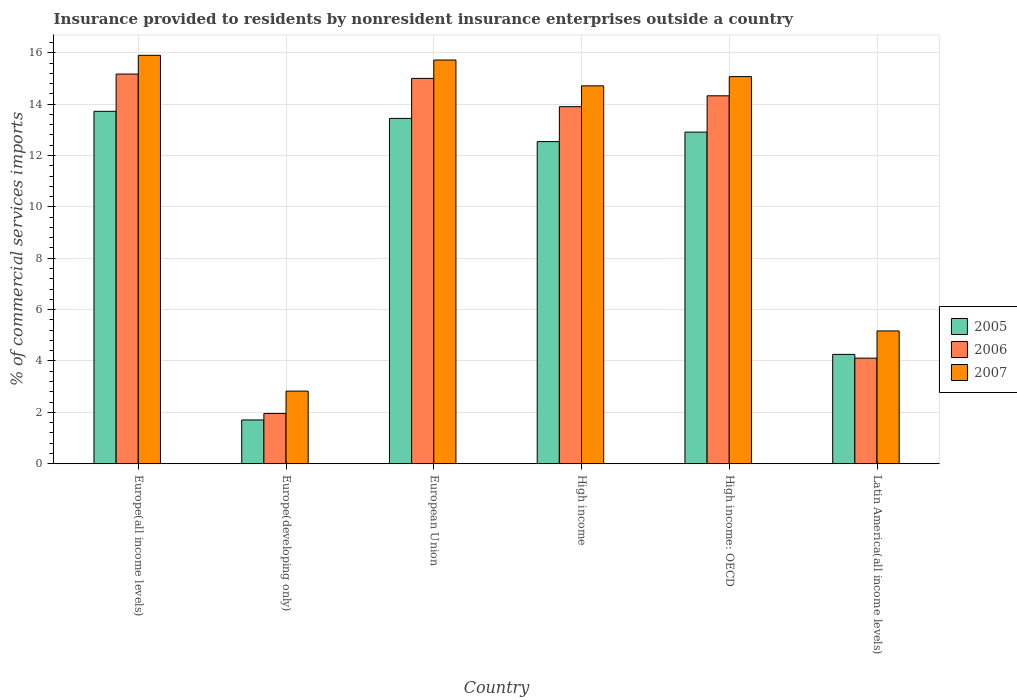How many different coloured bars are there?
Make the answer very short. 3. Are the number of bars on each tick of the X-axis equal?
Ensure brevity in your answer.  Yes. In how many cases, is the number of bars for a given country not equal to the number of legend labels?
Your response must be concise. 0. What is the Insurance provided to residents in 2005 in High income: OECD?
Your answer should be very brief. 12.91. Across all countries, what is the maximum Insurance provided to residents in 2005?
Provide a short and direct response. 13.72. Across all countries, what is the minimum Insurance provided to residents in 2006?
Offer a terse response. 1.96. In which country was the Insurance provided to residents in 2005 maximum?
Your response must be concise. Europe(all income levels). In which country was the Insurance provided to residents in 2005 minimum?
Offer a very short reply. Europe(developing only). What is the total Insurance provided to residents in 2005 in the graph?
Offer a terse response. 58.58. What is the difference between the Insurance provided to residents in 2006 in Europe(developing only) and that in High income?
Give a very brief answer. -11.94. What is the difference between the Insurance provided to residents in 2005 in Latin America(all income levels) and the Insurance provided to residents in 2006 in Europe(all income levels)?
Your answer should be compact. -10.91. What is the average Insurance provided to residents in 2005 per country?
Your answer should be compact. 9.76. What is the difference between the Insurance provided to residents of/in 2007 and Insurance provided to residents of/in 2005 in Latin America(all income levels)?
Offer a terse response. 0.91. In how many countries, is the Insurance provided to residents in 2007 greater than 8.4 %?
Offer a very short reply. 4. What is the ratio of the Insurance provided to residents in 2007 in Europe(developing only) to that in Latin America(all income levels)?
Give a very brief answer. 0.55. Is the difference between the Insurance provided to residents in 2007 in Europe(developing only) and High income: OECD greater than the difference between the Insurance provided to residents in 2005 in Europe(developing only) and High income: OECD?
Offer a very short reply. No. What is the difference between the highest and the second highest Insurance provided to residents in 2006?
Ensure brevity in your answer.  0.68. What is the difference between the highest and the lowest Insurance provided to residents in 2006?
Your answer should be compact. 13.21. In how many countries, is the Insurance provided to residents in 2005 greater than the average Insurance provided to residents in 2005 taken over all countries?
Provide a short and direct response. 4. Is it the case that in every country, the sum of the Insurance provided to residents in 2007 and Insurance provided to residents in 2006 is greater than the Insurance provided to residents in 2005?
Your response must be concise. Yes. How many bars are there?
Give a very brief answer. 18. Does the graph contain any zero values?
Offer a terse response. No. How are the legend labels stacked?
Provide a succinct answer. Vertical. What is the title of the graph?
Make the answer very short. Insurance provided to residents by nonresident insurance enterprises outside a country. Does "1973" appear as one of the legend labels in the graph?
Your answer should be compact. No. What is the label or title of the Y-axis?
Provide a succinct answer. % of commercial services imports. What is the % of commercial services imports in 2005 in Europe(all income levels)?
Ensure brevity in your answer.  13.72. What is the % of commercial services imports in 2006 in Europe(all income levels)?
Keep it short and to the point. 15.17. What is the % of commercial services imports in 2007 in Europe(all income levels)?
Offer a very short reply. 15.9. What is the % of commercial services imports of 2005 in Europe(developing only)?
Provide a short and direct response. 1.7. What is the % of commercial services imports of 2006 in Europe(developing only)?
Your answer should be compact. 1.96. What is the % of commercial services imports in 2007 in Europe(developing only)?
Offer a terse response. 2.83. What is the % of commercial services imports in 2005 in European Union?
Your answer should be compact. 13.45. What is the % of commercial services imports of 2006 in European Union?
Your response must be concise. 15. What is the % of commercial services imports in 2007 in European Union?
Offer a terse response. 15.72. What is the % of commercial services imports in 2005 in High income?
Your response must be concise. 12.54. What is the % of commercial services imports in 2006 in High income?
Provide a short and direct response. 13.9. What is the % of commercial services imports in 2007 in High income?
Offer a very short reply. 14.71. What is the % of commercial services imports in 2005 in High income: OECD?
Ensure brevity in your answer.  12.91. What is the % of commercial services imports of 2006 in High income: OECD?
Keep it short and to the point. 14.33. What is the % of commercial services imports of 2007 in High income: OECD?
Make the answer very short. 15.07. What is the % of commercial services imports of 2005 in Latin America(all income levels)?
Keep it short and to the point. 4.26. What is the % of commercial services imports of 2006 in Latin America(all income levels)?
Provide a succinct answer. 4.11. What is the % of commercial services imports in 2007 in Latin America(all income levels)?
Ensure brevity in your answer.  5.17. Across all countries, what is the maximum % of commercial services imports of 2005?
Provide a short and direct response. 13.72. Across all countries, what is the maximum % of commercial services imports of 2006?
Give a very brief answer. 15.17. Across all countries, what is the maximum % of commercial services imports of 2007?
Provide a short and direct response. 15.9. Across all countries, what is the minimum % of commercial services imports of 2005?
Offer a terse response. 1.7. Across all countries, what is the minimum % of commercial services imports in 2006?
Make the answer very short. 1.96. Across all countries, what is the minimum % of commercial services imports of 2007?
Ensure brevity in your answer.  2.83. What is the total % of commercial services imports of 2005 in the graph?
Provide a succinct answer. 58.58. What is the total % of commercial services imports of 2006 in the graph?
Your answer should be very brief. 64.47. What is the total % of commercial services imports of 2007 in the graph?
Keep it short and to the point. 69.4. What is the difference between the % of commercial services imports in 2005 in Europe(all income levels) and that in Europe(developing only)?
Give a very brief answer. 12.02. What is the difference between the % of commercial services imports of 2006 in Europe(all income levels) and that in Europe(developing only)?
Offer a terse response. 13.21. What is the difference between the % of commercial services imports in 2007 in Europe(all income levels) and that in Europe(developing only)?
Offer a very short reply. 13.07. What is the difference between the % of commercial services imports in 2005 in Europe(all income levels) and that in European Union?
Provide a succinct answer. 0.28. What is the difference between the % of commercial services imports in 2006 in Europe(all income levels) and that in European Union?
Give a very brief answer. 0.17. What is the difference between the % of commercial services imports in 2007 in Europe(all income levels) and that in European Union?
Offer a very short reply. 0.18. What is the difference between the % of commercial services imports of 2005 in Europe(all income levels) and that in High income?
Your answer should be very brief. 1.18. What is the difference between the % of commercial services imports of 2006 in Europe(all income levels) and that in High income?
Offer a terse response. 1.27. What is the difference between the % of commercial services imports of 2007 in Europe(all income levels) and that in High income?
Your answer should be very brief. 1.19. What is the difference between the % of commercial services imports of 2005 in Europe(all income levels) and that in High income: OECD?
Your answer should be compact. 0.81. What is the difference between the % of commercial services imports of 2006 in Europe(all income levels) and that in High income: OECD?
Provide a short and direct response. 0.85. What is the difference between the % of commercial services imports in 2007 in Europe(all income levels) and that in High income: OECD?
Your response must be concise. 0.83. What is the difference between the % of commercial services imports of 2005 in Europe(all income levels) and that in Latin America(all income levels)?
Offer a very short reply. 9.46. What is the difference between the % of commercial services imports of 2006 in Europe(all income levels) and that in Latin America(all income levels)?
Your answer should be compact. 11.06. What is the difference between the % of commercial services imports of 2007 in Europe(all income levels) and that in Latin America(all income levels)?
Give a very brief answer. 10.73. What is the difference between the % of commercial services imports in 2005 in Europe(developing only) and that in European Union?
Your response must be concise. -11.74. What is the difference between the % of commercial services imports in 2006 in Europe(developing only) and that in European Union?
Your answer should be compact. -13.05. What is the difference between the % of commercial services imports of 2007 in Europe(developing only) and that in European Union?
Make the answer very short. -12.89. What is the difference between the % of commercial services imports in 2005 in Europe(developing only) and that in High income?
Provide a short and direct response. -10.84. What is the difference between the % of commercial services imports of 2006 in Europe(developing only) and that in High income?
Give a very brief answer. -11.94. What is the difference between the % of commercial services imports of 2007 in Europe(developing only) and that in High income?
Give a very brief answer. -11.88. What is the difference between the % of commercial services imports in 2005 in Europe(developing only) and that in High income: OECD?
Keep it short and to the point. -11.21. What is the difference between the % of commercial services imports in 2006 in Europe(developing only) and that in High income: OECD?
Ensure brevity in your answer.  -12.37. What is the difference between the % of commercial services imports in 2007 in Europe(developing only) and that in High income: OECD?
Provide a succinct answer. -12.24. What is the difference between the % of commercial services imports in 2005 in Europe(developing only) and that in Latin America(all income levels)?
Give a very brief answer. -2.55. What is the difference between the % of commercial services imports of 2006 in Europe(developing only) and that in Latin America(all income levels)?
Ensure brevity in your answer.  -2.15. What is the difference between the % of commercial services imports in 2007 in Europe(developing only) and that in Latin America(all income levels)?
Your answer should be very brief. -2.34. What is the difference between the % of commercial services imports of 2005 in European Union and that in High income?
Provide a succinct answer. 0.9. What is the difference between the % of commercial services imports in 2006 in European Union and that in High income?
Your answer should be compact. 1.1. What is the difference between the % of commercial services imports of 2007 in European Union and that in High income?
Make the answer very short. 1.01. What is the difference between the % of commercial services imports in 2005 in European Union and that in High income: OECD?
Provide a succinct answer. 0.53. What is the difference between the % of commercial services imports in 2006 in European Union and that in High income: OECD?
Make the answer very short. 0.68. What is the difference between the % of commercial services imports in 2007 in European Union and that in High income: OECD?
Your answer should be compact. 0.64. What is the difference between the % of commercial services imports of 2005 in European Union and that in Latin America(all income levels)?
Provide a short and direct response. 9.19. What is the difference between the % of commercial services imports in 2006 in European Union and that in Latin America(all income levels)?
Your answer should be very brief. 10.89. What is the difference between the % of commercial services imports in 2007 in European Union and that in Latin America(all income levels)?
Provide a short and direct response. 10.55. What is the difference between the % of commercial services imports in 2005 in High income and that in High income: OECD?
Your response must be concise. -0.37. What is the difference between the % of commercial services imports in 2006 in High income and that in High income: OECD?
Keep it short and to the point. -0.42. What is the difference between the % of commercial services imports of 2007 in High income and that in High income: OECD?
Give a very brief answer. -0.36. What is the difference between the % of commercial services imports of 2005 in High income and that in Latin America(all income levels)?
Ensure brevity in your answer.  8.28. What is the difference between the % of commercial services imports in 2006 in High income and that in Latin America(all income levels)?
Offer a very short reply. 9.79. What is the difference between the % of commercial services imports in 2007 in High income and that in Latin America(all income levels)?
Provide a short and direct response. 9.54. What is the difference between the % of commercial services imports of 2005 in High income: OECD and that in Latin America(all income levels)?
Your answer should be very brief. 8.65. What is the difference between the % of commercial services imports of 2006 in High income: OECD and that in Latin America(all income levels)?
Provide a succinct answer. 10.21. What is the difference between the % of commercial services imports in 2007 in High income: OECD and that in Latin America(all income levels)?
Offer a terse response. 9.9. What is the difference between the % of commercial services imports in 2005 in Europe(all income levels) and the % of commercial services imports in 2006 in Europe(developing only)?
Provide a short and direct response. 11.76. What is the difference between the % of commercial services imports of 2005 in Europe(all income levels) and the % of commercial services imports of 2007 in Europe(developing only)?
Offer a terse response. 10.89. What is the difference between the % of commercial services imports in 2006 in Europe(all income levels) and the % of commercial services imports in 2007 in Europe(developing only)?
Your answer should be compact. 12.34. What is the difference between the % of commercial services imports in 2005 in Europe(all income levels) and the % of commercial services imports in 2006 in European Union?
Ensure brevity in your answer.  -1.28. What is the difference between the % of commercial services imports of 2005 in Europe(all income levels) and the % of commercial services imports of 2007 in European Union?
Your answer should be compact. -2. What is the difference between the % of commercial services imports of 2006 in Europe(all income levels) and the % of commercial services imports of 2007 in European Union?
Keep it short and to the point. -0.55. What is the difference between the % of commercial services imports of 2005 in Europe(all income levels) and the % of commercial services imports of 2006 in High income?
Offer a very short reply. -0.18. What is the difference between the % of commercial services imports in 2005 in Europe(all income levels) and the % of commercial services imports in 2007 in High income?
Offer a terse response. -0.99. What is the difference between the % of commercial services imports in 2006 in Europe(all income levels) and the % of commercial services imports in 2007 in High income?
Offer a terse response. 0.46. What is the difference between the % of commercial services imports in 2005 in Europe(all income levels) and the % of commercial services imports in 2006 in High income: OECD?
Provide a short and direct response. -0.6. What is the difference between the % of commercial services imports in 2005 in Europe(all income levels) and the % of commercial services imports in 2007 in High income: OECD?
Your answer should be very brief. -1.35. What is the difference between the % of commercial services imports in 2006 in Europe(all income levels) and the % of commercial services imports in 2007 in High income: OECD?
Your answer should be compact. 0.1. What is the difference between the % of commercial services imports of 2005 in Europe(all income levels) and the % of commercial services imports of 2006 in Latin America(all income levels)?
Give a very brief answer. 9.61. What is the difference between the % of commercial services imports of 2005 in Europe(all income levels) and the % of commercial services imports of 2007 in Latin America(all income levels)?
Offer a terse response. 8.55. What is the difference between the % of commercial services imports in 2006 in Europe(all income levels) and the % of commercial services imports in 2007 in Latin America(all income levels)?
Make the answer very short. 10. What is the difference between the % of commercial services imports of 2005 in Europe(developing only) and the % of commercial services imports of 2006 in European Union?
Give a very brief answer. -13.3. What is the difference between the % of commercial services imports of 2005 in Europe(developing only) and the % of commercial services imports of 2007 in European Union?
Offer a terse response. -14.01. What is the difference between the % of commercial services imports in 2006 in Europe(developing only) and the % of commercial services imports in 2007 in European Union?
Your response must be concise. -13.76. What is the difference between the % of commercial services imports of 2005 in Europe(developing only) and the % of commercial services imports of 2006 in High income?
Offer a terse response. -12.2. What is the difference between the % of commercial services imports in 2005 in Europe(developing only) and the % of commercial services imports in 2007 in High income?
Your answer should be compact. -13.01. What is the difference between the % of commercial services imports of 2006 in Europe(developing only) and the % of commercial services imports of 2007 in High income?
Your response must be concise. -12.75. What is the difference between the % of commercial services imports in 2005 in Europe(developing only) and the % of commercial services imports in 2006 in High income: OECD?
Keep it short and to the point. -12.62. What is the difference between the % of commercial services imports in 2005 in Europe(developing only) and the % of commercial services imports in 2007 in High income: OECD?
Provide a short and direct response. -13.37. What is the difference between the % of commercial services imports in 2006 in Europe(developing only) and the % of commercial services imports in 2007 in High income: OECD?
Offer a very short reply. -13.11. What is the difference between the % of commercial services imports in 2005 in Europe(developing only) and the % of commercial services imports in 2006 in Latin America(all income levels)?
Your response must be concise. -2.41. What is the difference between the % of commercial services imports in 2005 in Europe(developing only) and the % of commercial services imports in 2007 in Latin America(all income levels)?
Make the answer very short. -3.47. What is the difference between the % of commercial services imports in 2006 in Europe(developing only) and the % of commercial services imports in 2007 in Latin America(all income levels)?
Provide a succinct answer. -3.21. What is the difference between the % of commercial services imports in 2005 in European Union and the % of commercial services imports in 2006 in High income?
Make the answer very short. -0.46. What is the difference between the % of commercial services imports in 2005 in European Union and the % of commercial services imports in 2007 in High income?
Give a very brief answer. -1.27. What is the difference between the % of commercial services imports in 2006 in European Union and the % of commercial services imports in 2007 in High income?
Your answer should be compact. 0.29. What is the difference between the % of commercial services imports of 2005 in European Union and the % of commercial services imports of 2006 in High income: OECD?
Provide a succinct answer. -0.88. What is the difference between the % of commercial services imports in 2005 in European Union and the % of commercial services imports in 2007 in High income: OECD?
Offer a terse response. -1.63. What is the difference between the % of commercial services imports in 2006 in European Union and the % of commercial services imports in 2007 in High income: OECD?
Give a very brief answer. -0.07. What is the difference between the % of commercial services imports in 2005 in European Union and the % of commercial services imports in 2006 in Latin America(all income levels)?
Give a very brief answer. 9.34. What is the difference between the % of commercial services imports in 2005 in European Union and the % of commercial services imports in 2007 in Latin America(all income levels)?
Keep it short and to the point. 8.28. What is the difference between the % of commercial services imports in 2006 in European Union and the % of commercial services imports in 2007 in Latin America(all income levels)?
Provide a short and direct response. 9.83. What is the difference between the % of commercial services imports in 2005 in High income and the % of commercial services imports in 2006 in High income: OECD?
Your answer should be very brief. -1.78. What is the difference between the % of commercial services imports in 2005 in High income and the % of commercial services imports in 2007 in High income: OECD?
Make the answer very short. -2.53. What is the difference between the % of commercial services imports of 2006 in High income and the % of commercial services imports of 2007 in High income: OECD?
Your response must be concise. -1.17. What is the difference between the % of commercial services imports in 2005 in High income and the % of commercial services imports in 2006 in Latin America(all income levels)?
Offer a terse response. 8.43. What is the difference between the % of commercial services imports in 2005 in High income and the % of commercial services imports in 2007 in Latin America(all income levels)?
Keep it short and to the point. 7.37. What is the difference between the % of commercial services imports of 2006 in High income and the % of commercial services imports of 2007 in Latin America(all income levels)?
Your answer should be compact. 8.73. What is the difference between the % of commercial services imports in 2005 in High income: OECD and the % of commercial services imports in 2006 in Latin America(all income levels)?
Provide a succinct answer. 8.8. What is the difference between the % of commercial services imports in 2005 in High income: OECD and the % of commercial services imports in 2007 in Latin America(all income levels)?
Your answer should be compact. 7.74. What is the difference between the % of commercial services imports of 2006 in High income: OECD and the % of commercial services imports of 2007 in Latin America(all income levels)?
Your answer should be very brief. 9.15. What is the average % of commercial services imports in 2005 per country?
Offer a very short reply. 9.76. What is the average % of commercial services imports of 2006 per country?
Keep it short and to the point. 10.75. What is the average % of commercial services imports in 2007 per country?
Provide a succinct answer. 11.57. What is the difference between the % of commercial services imports of 2005 and % of commercial services imports of 2006 in Europe(all income levels)?
Offer a very short reply. -1.45. What is the difference between the % of commercial services imports of 2005 and % of commercial services imports of 2007 in Europe(all income levels)?
Make the answer very short. -2.18. What is the difference between the % of commercial services imports of 2006 and % of commercial services imports of 2007 in Europe(all income levels)?
Give a very brief answer. -0.73. What is the difference between the % of commercial services imports of 2005 and % of commercial services imports of 2006 in Europe(developing only)?
Make the answer very short. -0.25. What is the difference between the % of commercial services imports of 2005 and % of commercial services imports of 2007 in Europe(developing only)?
Provide a succinct answer. -1.12. What is the difference between the % of commercial services imports in 2006 and % of commercial services imports in 2007 in Europe(developing only)?
Your answer should be very brief. -0.87. What is the difference between the % of commercial services imports in 2005 and % of commercial services imports in 2006 in European Union?
Give a very brief answer. -1.56. What is the difference between the % of commercial services imports of 2005 and % of commercial services imports of 2007 in European Union?
Offer a terse response. -2.27. What is the difference between the % of commercial services imports in 2006 and % of commercial services imports in 2007 in European Union?
Provide a short and direct response. -0.71. What is the difference between the % of commercial services imports in 2005 and % of commercial services imports in 2006 in High income?
Ensure brevity in your answer.  -1.36. What is the difference between the % of commercial services imports in 2005 and % of commercial services imports in 2007 in High income?
Make the answer very short. -2.17. What is the difference between the % of commercial services imports in 2006 and % of commercial services imports in 2007 in High income?
Your answer should be very brief. -0.81. What is the difference between the % of commercial services imports of 2005 and % of commercial services imports of 2006 in High income: OECD?
Give a very brief answer. -1.41. What is the difference between the % of commercial services imports of 2005 and % of commercial services imports of 2007 in High income: OECD?
Keep it short and to the point. -2.16. What is the difference between the % of commercial services imports of 2006 and % of commercial services imports of 2007 in High income: OECD?
Ensure brevity in your answer.  -0.75. What is the difference between the % of commercial services imports in 2005 and % of commercial services imports in 2006 in Latin America(all income levels)?
Your answer should be very brief. 0.15. What is the difference between the % of commercial services imports in 2005 and % of commercial services imports in 2007 in Latin America(all income levels)?
Provide a short and direct response. -0.91. What is the difference between the % of commercial services imports of 2006 and % of commercial services imports of 2007 in Latin America(all income levels)?
Your answer should be very brief. -1.06. What is the ratio of the % of commercial services imports in 2005 in Europe(all income levels) to that in Europe(developing only)?
Offer a terse response. 8.05. What is the ratio of the % of commercial services imports in 2006 in Europe(all income levels) to that in Europe(developing only)?
Your answer should be very brief. 7.75. What is the ratio of the % of commercial services imports of 2007 in Europe(all income levels) to that in Europe(developing only)?
Offer a terse response. 5.62. What is the ratio of the % of commercial services imports in 2005 in Europe(all income levels) to that in European Union?
Your answer should be very brief. 1.02. What is the ratio of the % of commercial services imports in 2006 in Europe(all income levels) to that in European Union?
Keep it short and to the point. 1.01. What is the ratio of the % of commercial services imports in 2007 in Europe(all income levels) to that in European Union?
Make the answer very short. 1.01. What is the ratio of the % of commercial services imports in 2005 in Europe(all income levels) to that in High income?
Your answer should be compact. 1.09. What is the ratio of the % of commercial services imports of 2006 in Europe(all income levels) to that in High income?
Make the answer very short. 1.09. What is the ratio of the % of commercial services imports in 2007 in Europe(all income levels) to that in High income?
Your answer should be compact. 1.08. What is the ratio of the % of commercial services imports of 2005 in Europe(all income levels) to that in High income: OECD?
Your answer should be compact. 1.06. What is the ratio of the % of commercial services imports in 2006 in Europe(all income levels) to that in High income: OECD?
Give a very brief answer. 1.06. What is the ratio of the % of commercial services imports of 2007 in Europe(all income levels) to that in High income: OECD?
Make the answer very short. 1.05. What is the ratio of the % of commercial services imports in 2005 in Europe(all income levels) to that in Latin America(all income levels)?
Offer a very short reply. 3.22. What is the ratio of the % of commercial services imports in 2006 in Europe(all income levels) to that in Latin America(all income levels)?
Ensure brevity in your answer.  3.69. What is the ratio of the % of commercial services imports in 2007 in Europe(all income levels) to that in Latin America(all income levels)?
Your answer should be compact. 3.08. What is the ratio of the % of commercial services imports of 2005 in Europe(developing only) to that in European Union?
Make the answer very short. 0.13. What is the ratio of the % of commercial services imports in 2006 in Europe(developing only) to that in European Union?
Provide a short and direct response. 0.13. What is the ratio of the % of commercial services imports in 2007 in Europe(developing only) to that in European Union?
Provide a succinct answer. 0.18. What is the ratio of the % of commercial services imports of 2005 in Europe(developing only) to that in High income?
Your answer should be very brief. 0.14. What is the ratio of the % of commercial services imports in 2006 in Europe(developing only) to that in High income?
Provide a succinct answer. 0.14. What is the ratio of the % of commercial services imports in 2007 in Europe(developing only) to that in High income?
Offer a very short reply. 0.19. What is the ratio of the % of commercial services imports of 2005 in Europe(developing only) to that in High income: OECD?
Provide a short and direct response. 0.13. What is the ratio of the % of commercial services imports in 2006 in Europe(developing only) to that in High income: OECD?
Offer a very short reply. 0.14. What is the ratio of the % of commercial services imports of 2007 in Europe(developing only) to that in High income: OECD?
Your answer should be very brief. 0.19. What is the ratio of the % of commercial services imports in 2005 in Europe(developing only) to that in Latin America(all income levels)?
Your answer should be very brief. 0.4. What is the ratio of the % of commercial services imports of 2006 in Europe(developing only) to that in Latin America(all income levels)?
Offer a very short reply. 0.48. What is the ratio of the % of commercial services imports of 2007 in Europe(developing only) to that in Latin America(all income levels)?
Provide a short and direct response. 0.55. What is the ratio of the % of commercial services imports of 2005 in European Union to that in High income?
Offer a very short reply. 1.07. What is the ratio of the % of commercial services imports in 2006 in European Union to that in High income?
Make the answer very short. 1.08. What is the ratio of the % of commercial services imports of 2007 in European Union to that in High income?
Provide a succinct answer. 1.07. What is the ratio of the % of commercial services imports in 2005 in European Union to that in High income: OECD?
Offer a very short reply. 1.04. What is the ratio of the % of commercial services imports in 2006 in European Union to that in High income: OECD?
Offer a terse response. 1.05. What is the ratio of the % of commercial services imports in 2007 in European Union to that in High income: OECD?
Provide a succinct answer. 1.04. What is the ratio of the % of commercial services imports of 2005 in European Union to that in Latin America(all income levels)?
Your answer should be very brief. 3.16. What is the ratio of the % of commercial services imports in 2006 in European Union to that in Latin America(all income levels)?
Keep it short and to the point. 3.65. What is the ratio of the % of commercial services imports in 2007 in European Union to that in Latin America(all income levels)?
Your answer should be compact. 3.04. What is the ratio of the % of commercial services imports in 2005 in High income to that in High income: OECD?
Your response must be concise. 0.97. What is the ratio of the % of commercial services imports in 2006 in High income to that in High income: OECD?
Provide a succinct answer. 0.97. What is the ratio of the % of commercial services imports of 2007 in High income to that in High income: OECD?
Make the answer very short. 0.98. What is the ratio of the % of commercial services imports in 2005 in High income to that in Latin America(all income levels)?
Provide a short and direct response. 2.95. What is the ratio of the % of commercial services imports of 2006 in High income to that in Latin America(all income levels)?
Keep it short and to the point. 3.38. What is the ratio of the % of commercial services imports in 2007 in High income to that in Latin America(all income levels)?
Your answer should be compact. 2.85. What is the ratio of the % of commercial services imports of 2005 in High income: OECD to that in Latin America(all income levels)?
Offer a terse response. 3.03. What is the ratio of the % of commercial services imports of 2006 in High income: OECD to that in Latin America(all income levels)?
Keep it short and to the point. 3.48. What is the ratio of the % of commercial services imports of 2007 in High income: OECD to that in Latin America(all income levels)?
Your answer should be very brief. 2.92. What is the difference between the highest and the second highest % of commercial services imports of 2005?
Provide a succinct answer. 0.28. What is the difference between the highest and the second highest % of commercial services imports in 2006?
Keep it short and to the point. 0.17. What is the difference between the highest and the second highest % of commercial services imports of 2007?
Offer a terse response. 0.18. What is the difference between the highest and the lowest % of commercial services imports of 2005?
Make the answer very short. 12.02. What is the difference between the highest and the lowest % of commercial services imports in 2006?
Keep it short and to the point. 13.21. What is the difference between the highest and the lowest % of commercial services imports in 2007?
Offer a terse response. 13.07. 